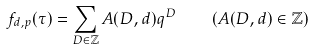<formula> <loc_0><loc_0><loc_500><loc_500>f _ { d , p } ( \tau ) = \sum _ { D \in \mathbb { Z } } A ( D , d ) q ^ { D } \quad ( A ( D , d ) \in \mathbb { Z } )</formula> 